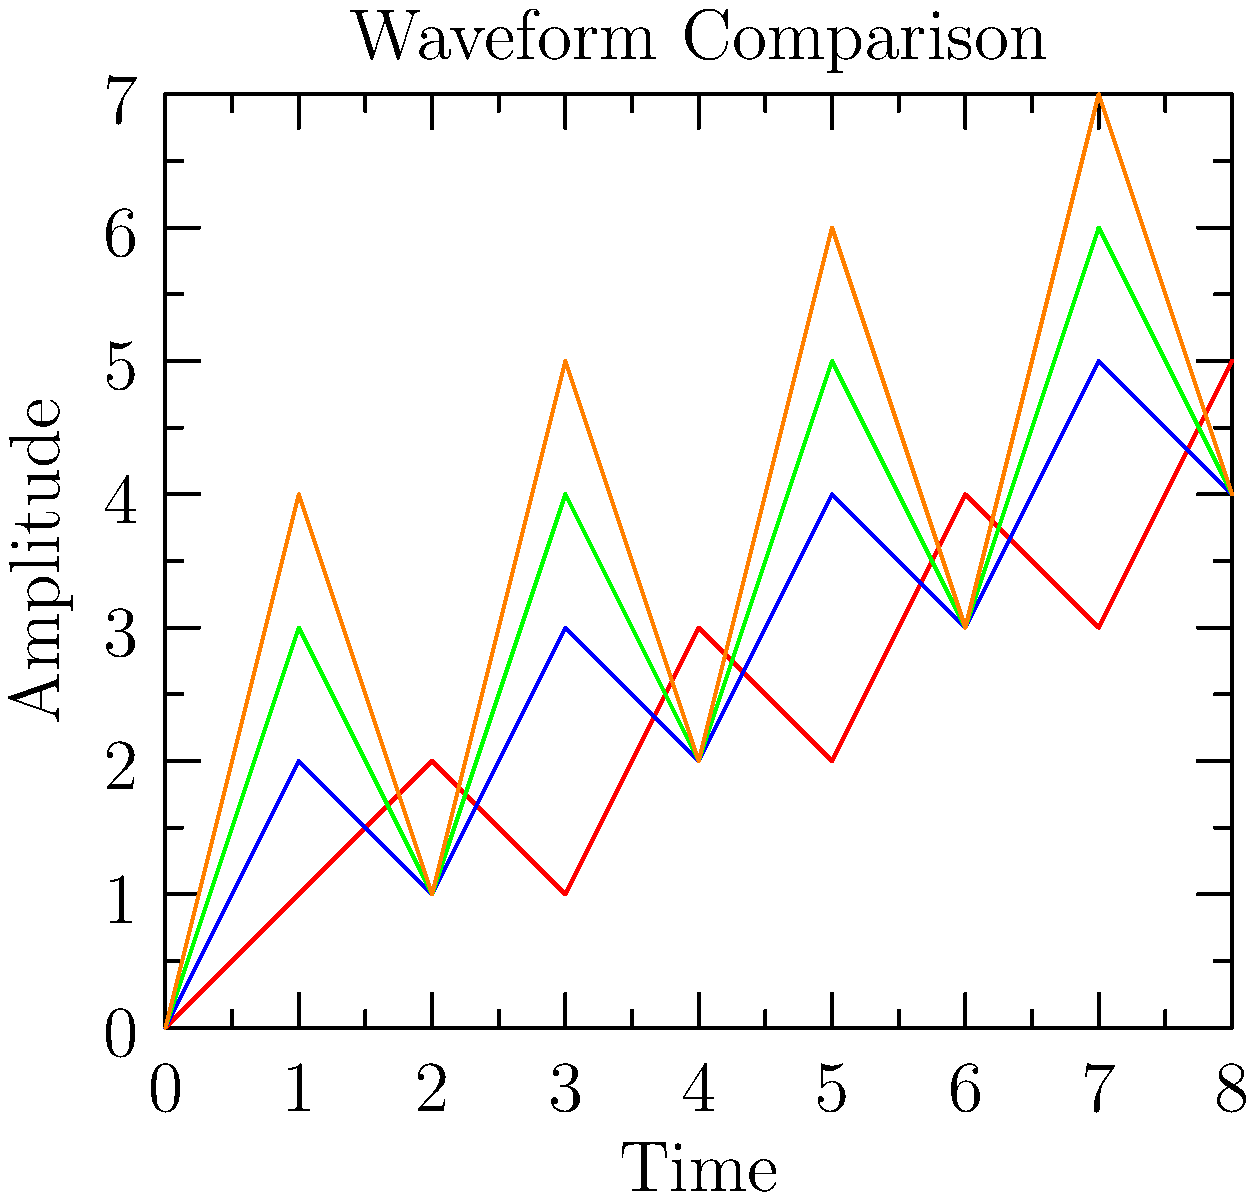Match the waveforms A, B, C, and D to their corresponding compression ratios: 2:1, 4:1, 8:1, and 16:1. Which waveform represents the highest compression ratio? To answer this question, we need to analyze the waveforms and understand how compression affects audio signals:

1. Compression ratios indicate how much the data is reduced. Higher ratios mean more compression and potentially more loss of information.

2. In audio compression, higher compression ratios typically result in smoother waveforms with less detail.

3. Analyzing the waveforms:
   - Waveform A (red) has the most detail and variation.
   - Waveform B (blue) has slightly less detail than A.
   - Waveform C (green) is smoother than B, with less variation.
   - Waveform D (orange) is the smoothest, with the least variation.

4. Matching compression ratios:
   - A (red) likely corresponds to 2:1 (lowest compression)
   - B (blue) likely corresponds to 4:1
   - C (green) likely corresponds to 8:1
   - D (orange) likely corresponds to 16:1 (highest compression)

5. The waveform representing the highest compression ratio (16:1) is the smoothest one, which is waveform D (orange).

This analysis is consistent with how audio codecs work in the context of Media Source Extensions and Encrypted Media Extensions, where higher compression ratios often result in less detailed audio representations.
Answer: D (orange) 